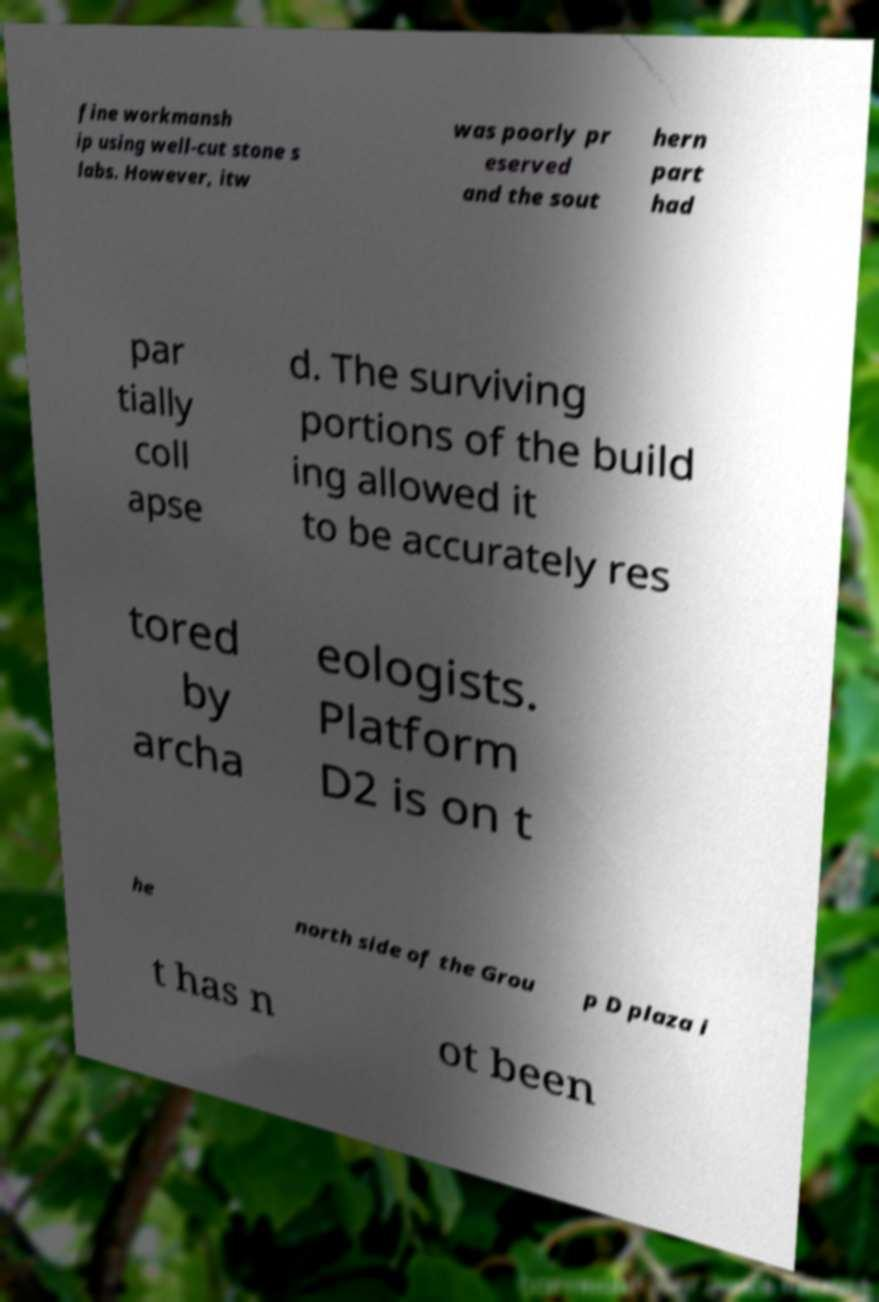Could you extract and type out the text from this image? fine workmansh ip using well-cut stone s labs. However, itw was poorly pr eserved and the sout hern part had par tially coll apse d. The surviving portions of the build ing allowed it to be accurately res tored by archa eologists. Platform D2 is on t he north side of the Grou p D plaza i t has n ot been 